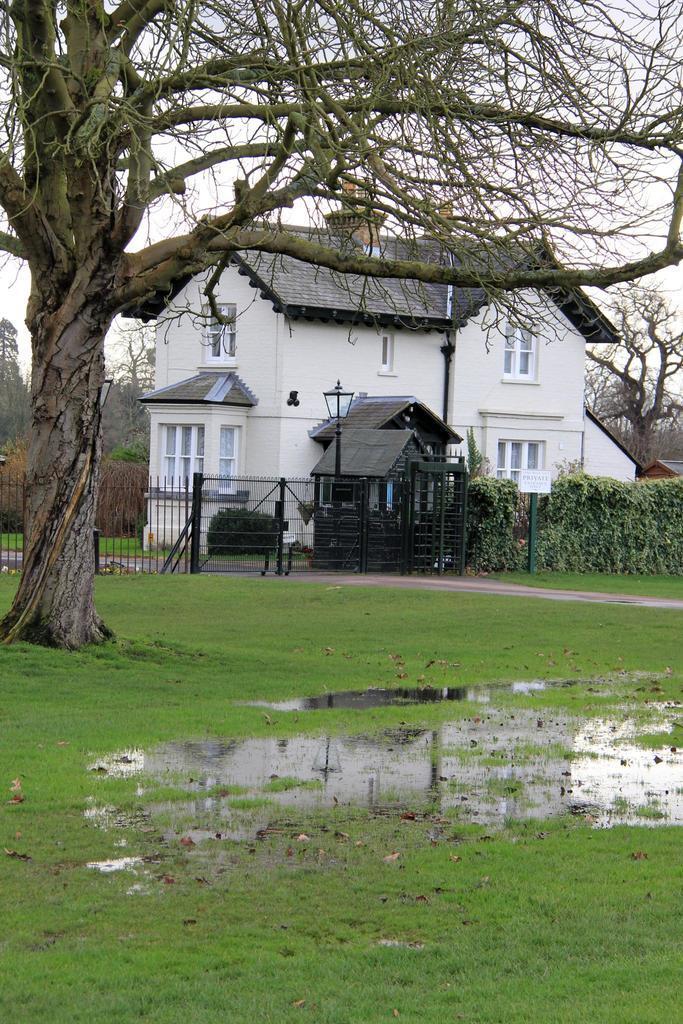In one or two sentences, can you explain what this image depicts? This image consists of a house in white color. To the left, there is a tree. At the bottom, there is green grass along with the water. To the right, there are plants. In the front, there is a gate. 